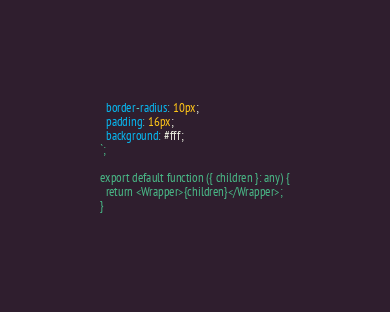Convert code to text. <code><loc_0><loc_0><loc_500><loc_500><_TypeScript_>  border-radius: 10px;
  padding: 16px;
  background: #fff;
`;

export default function ({ children }: any) {
  return <Wrapper>{children}</Wrapper>;
}
</code> 